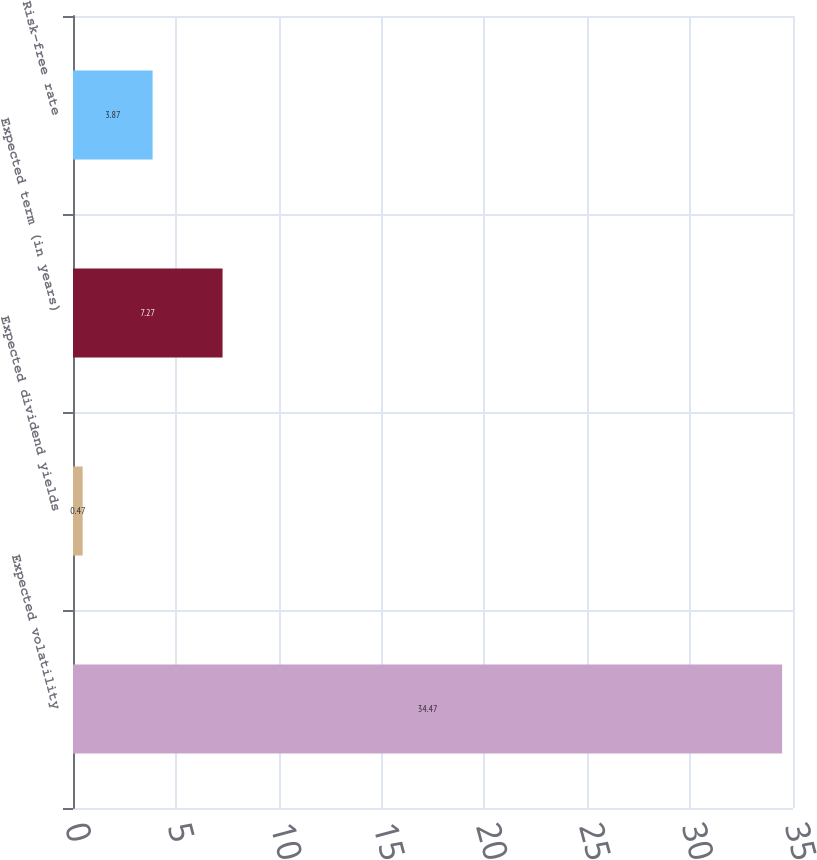Convert chart. <chart><loc_0><loc_0><loc_500><loc_500><bar_chart><fcel>Expected volatility<fcel>Expected dividend yields<fcel>Expected term (in years)<fcel>Risk-free rate<nl><fcel>34.47<fcel>0.47<fcel>7.27<fcel>3.87<nl></chart> 